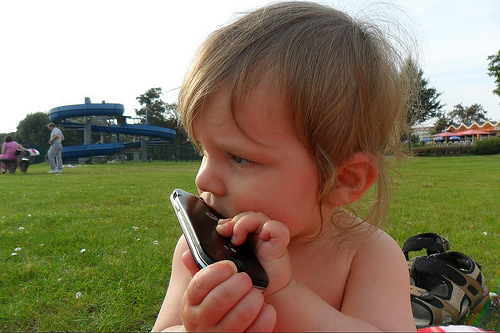What is the child doing in the picture? The child seems to be holding a mobile phone up to their ear, which suggests they might be imitating the act of having a conversation on the phone. This candid moment showcases the curiosity and mimicry often seen in childhood, as the young one explores the functions of everyday objects. 